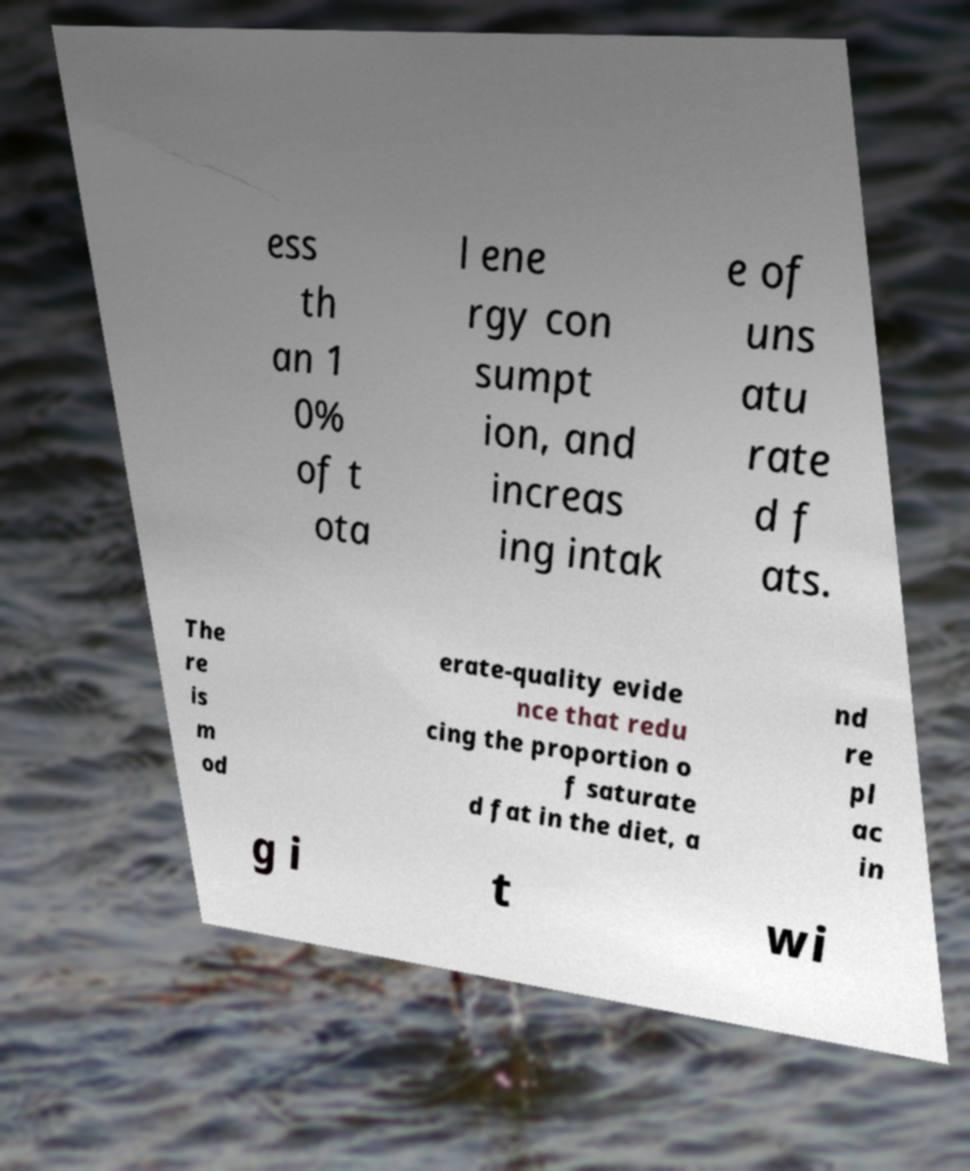Could you assist in decoding the text presented in this image and type it out clearly? ess th an 1 0% of t ota l ene rgy con sumpt ion, and increas ing intak e of uns atu rate d f ats. The re is m od erate-quality evide nce that redu cing the proportion o f saturate d fat in the diet, a nd re pl ac in g i t wi 